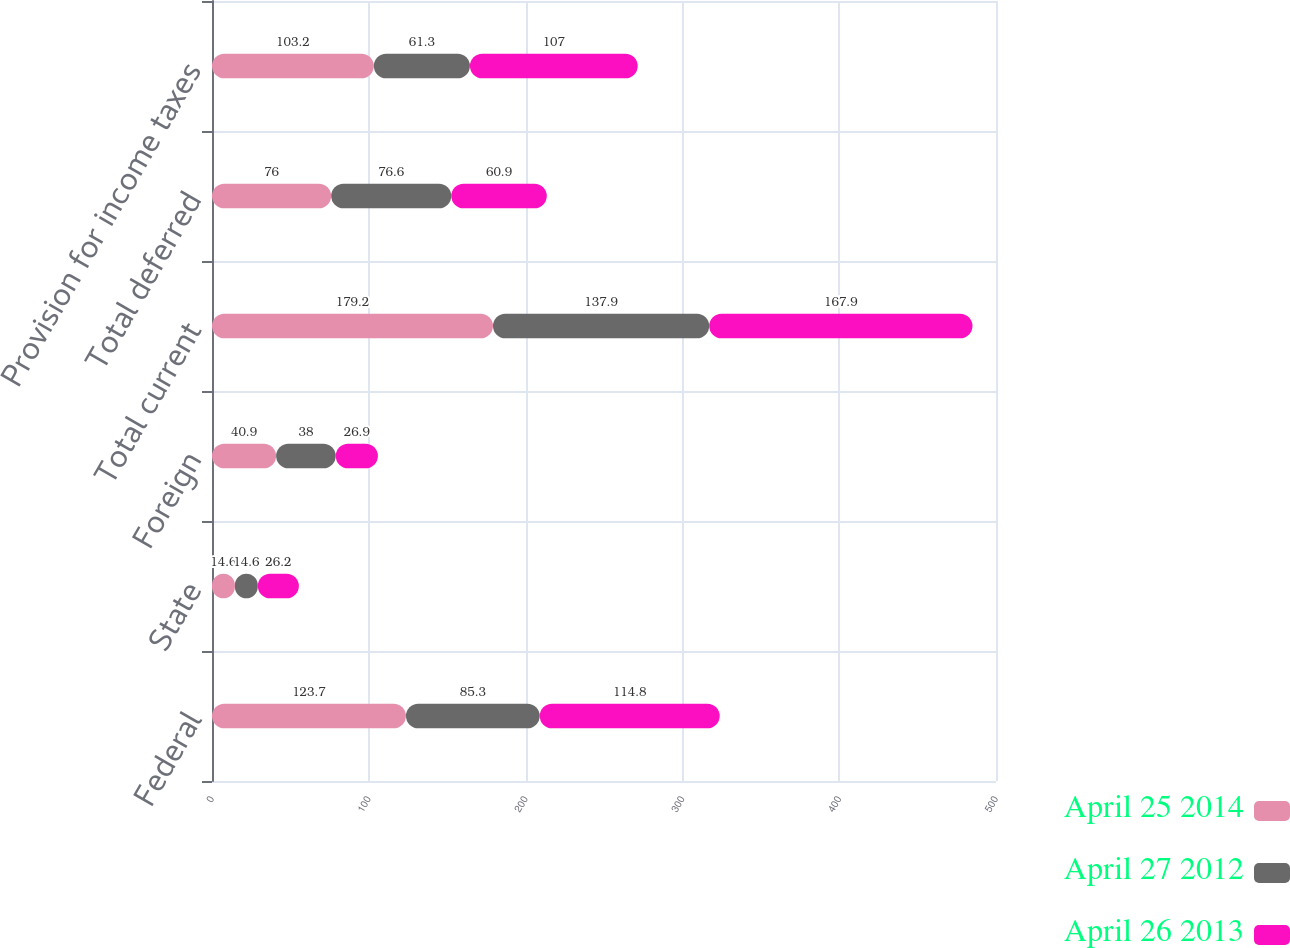Convert chart. <chart><loc_0><loc_0><loc_500><loc_500><stacked_bar_chart><ecel><fcel>Federal<fcel>State<fcel>Foreign<fcel>Total current<fcel>Total deferred<fcel>Provision for income taxes<nl><fcel>April 25 2014<fcel>123.7<fcel>14.6<fcel>40.9<fcel>179.2<fcel>76<fcel>103.2<nl><fcel>April 27 2012<fcel>85.3<fcel>14.6<fcel>38<fcel>137.9<fcel>76.6<fcel>61.3<nl><fcel>April 26 2013<fcel>114.8<fcel>26.2<fcel>26.9<fcel>167.9<fcel>60.9<fcel>107<nl></chart> 